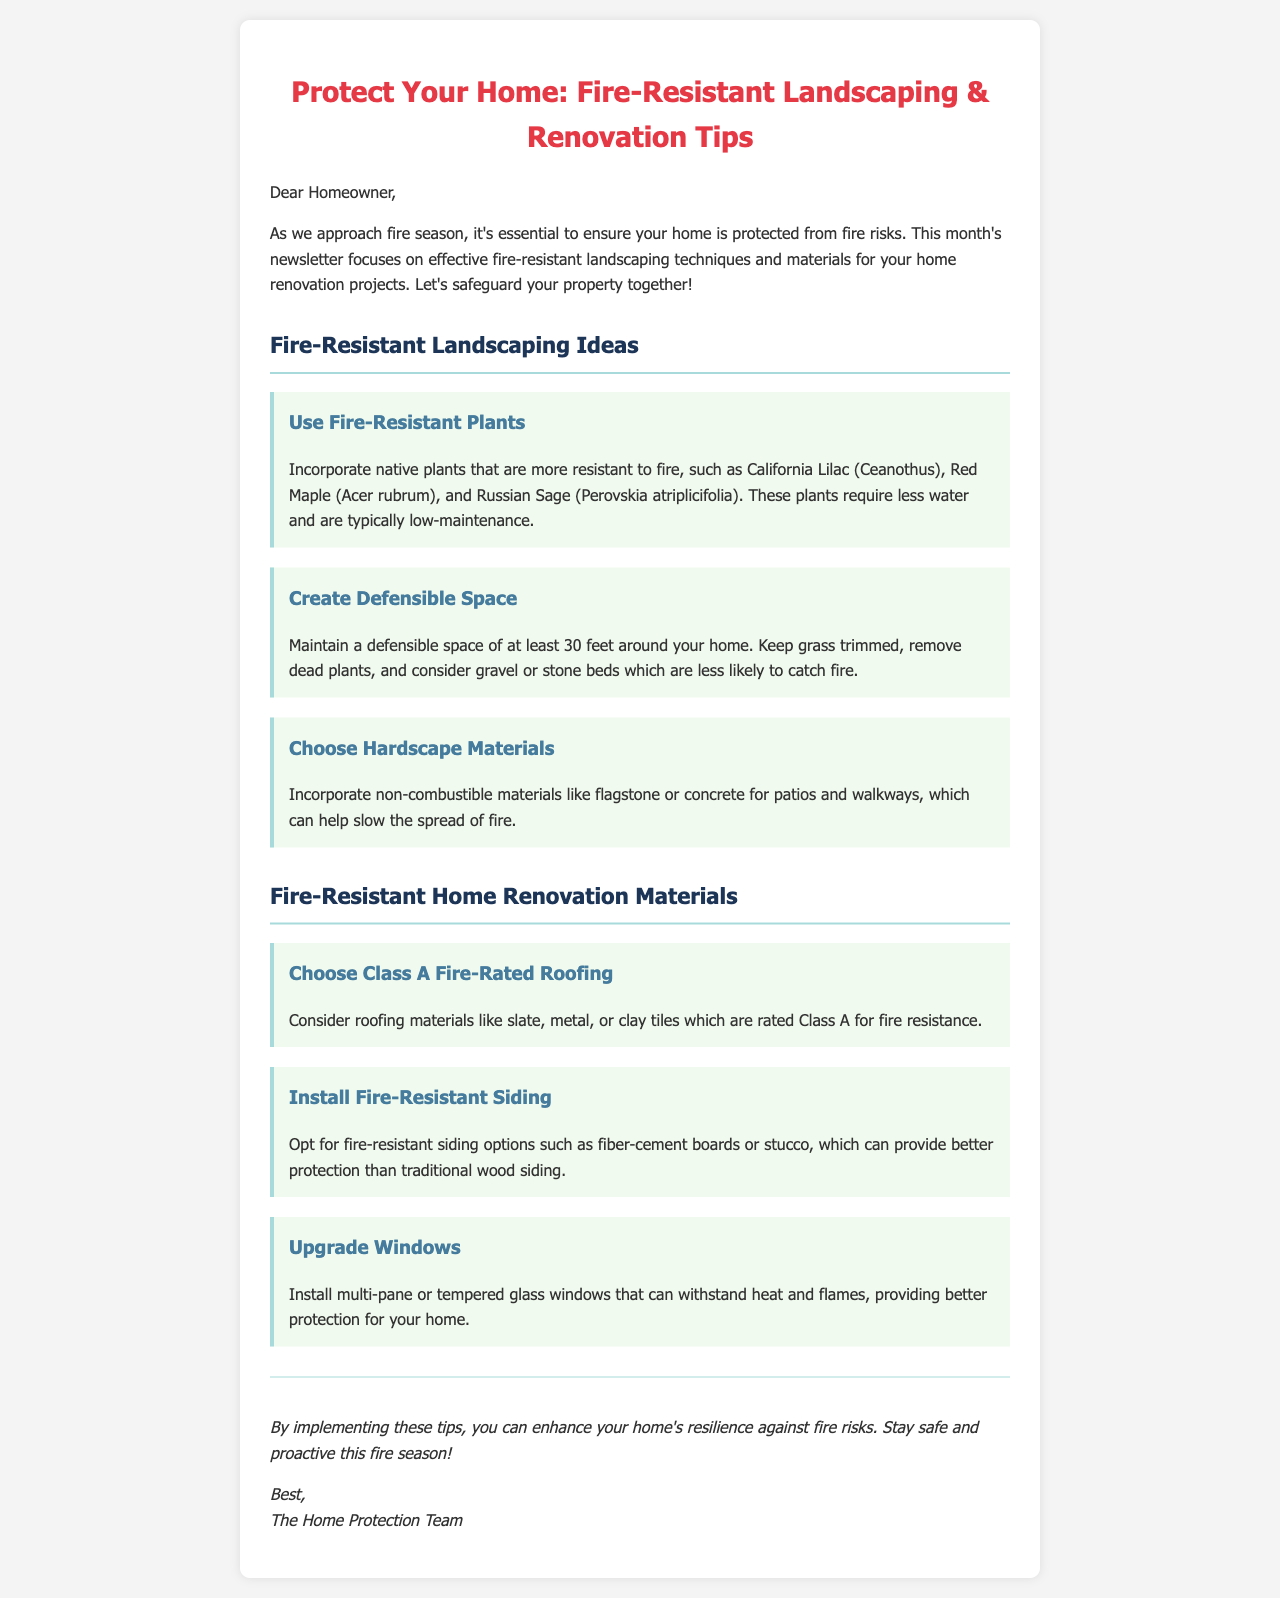what is the title of the newsletter? The title is prominently displayed at the top of the newsletter, summarizing its focus on fire protection.
Answer: Protect Your Home: Fire-Resistant Landscaping & Renovation Tips how many feet of defensible space should be maintained around the home? The document specifies the required distance for a defensible space, highlighting its importance for fire safety.
Answer: 30 feet name one fire-resistant plant mentioned in the newsletter. The newsletter lists specific native plants that are more resistant to fire as part of landscaping recommendations.
Answer: California Lilac what type of siding is recommended for fire resistance? The document suggests certain materials for siding that provide better protection against fire.
Answer: fiber-cement boards which roofing material is rated Class A for fire resistance? The newsletter provides examples of roofing materials that have a Class A fire rating, enhancing fire safety for homes.
Answer: slate what material is suggested for patios and walkways? The document recommends certain hardscape materials that can help slow the spread of fire in landscaping projects.
Answer: flagstone what type of windows should be installed for better heat resistance? The newsletter advises on window types that provide enhanced protection against fire threats.
Answer: multi-pane or tempered glass who is the newsletter addressed to? The greeting at the beginning of the newsletter specifies the intended audience for the message and tips.
Answer: Homeowner 